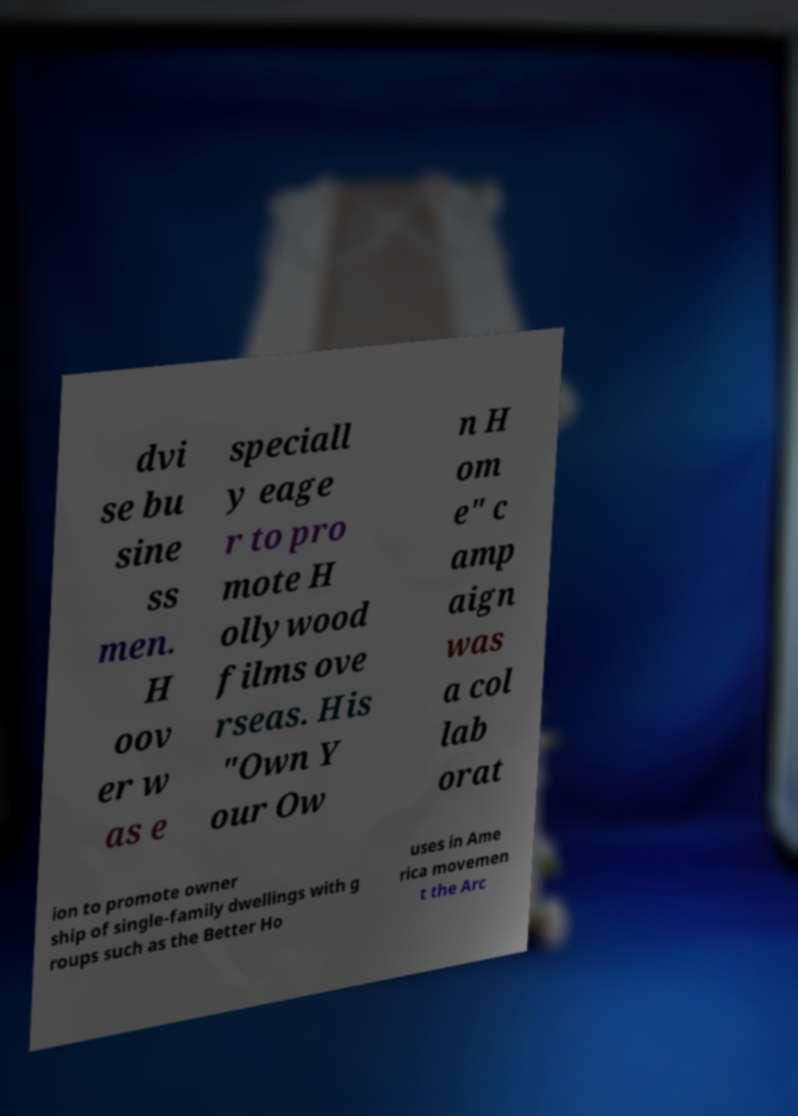Could you assist in decoding the text presented in this image and type it out clearly? dvi se bu sine ss men. H oov er w as e speciall y eage r to pro mote H ollywood films ove rseas. His "Own Y our Ow n H om e" c amp aign was a col lab orat ion to promote owner ship of single-family dwellings with g roups such as the Better Ho uses in Ame rica movemen t the Arc 